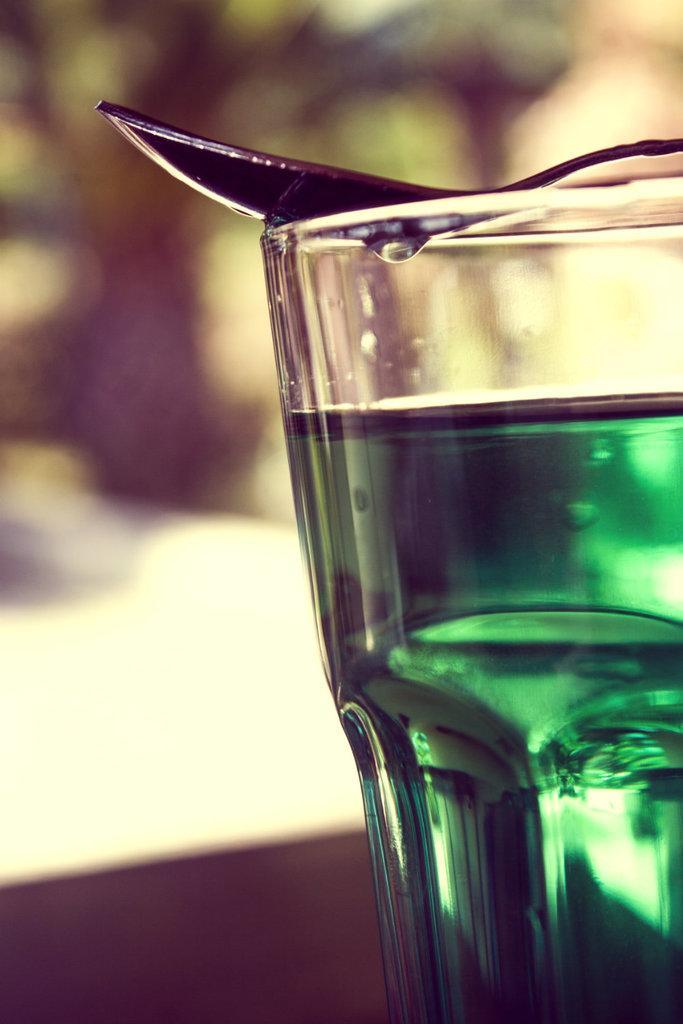Please provide a concise description of this image. In this image there is a glass truncated towards the right of the image, there is the drink in the glass, there is a spoon truncated towards the right of the image, the background of the image is blurred. 